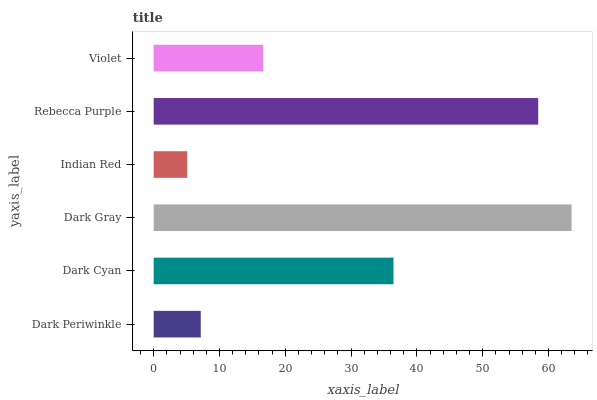Is Indian Red the minimum?
Answer yes or no. Yes. Is Dark Gray the maximum?
Answer yes or no. Yes. Is Dark Cyan the minimum?
Answer yes or no. No. Is Dark Cyan the maximum?
Answer yes or no. No. Is Dark Cyan greater than Dark Periwinkle?
Answer yes or no. Yes. Is Dark Periwinkle less than Dark Cyan?
Answer yes or no. Yes. Is Dark Periwinkle greater than Dark Cyan?
Answer yes or no. No. Is Dark Cyan less than Dark Periwinkle?
Answer yes or no. No. Is Dark Cyan the high median?
Answer yes or no. Yes. Is Violet the low median?
Answer yes or no. Yes. Is Indian Red the high median?
Answer yes or no. No. Is Dark Gray the low median?
Answer yes or no. No. 